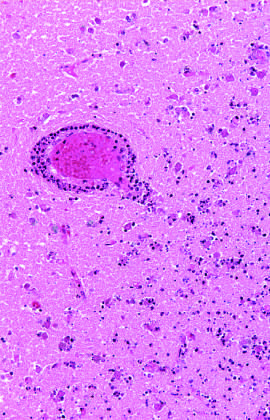s subacute endocarditis intact?
Answer the question using a single word or phrase. No 